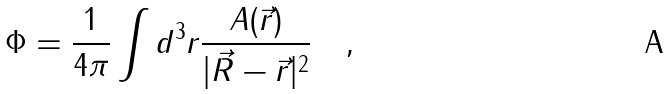Convert formula to latex. <formula><loc_0><loc_0><loc_500><loc_500>\Phi = \frac { 1 } { 4 \pi } \int d ^ { 3 } r \frac { A ( \vec { r } ) } { | \vec { R } - \vec { r } | ^ { 2 } } \quad ,</formula> 